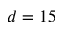Convert formula to latex. <formula><loc_0><loc_0><loc_500><loc_500>d = 1 5</formula> 